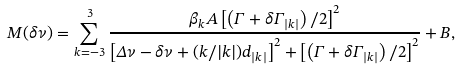<formula> <loc_0><loc_0><loc_500><loc_500>M ( \delta \nu ) = \sum _ { k = - 3 } ^ { 3 } \frac { \beta _ { k } A \left [ \left ( \Gamma + \delta \Gamma _ { | k | } \right ) / 2 \right ] ^ { 2 } } { \left [ \Delta \nu - \delta \nu + ( k / | k | ) d _ { | k | } \right ] ^ { 2 } + \left [ \left ( \Gamma + \delta \Gamma _ { | k | } \right ) / 2 \right ] ^ { 2 } } + B ,</formula> 